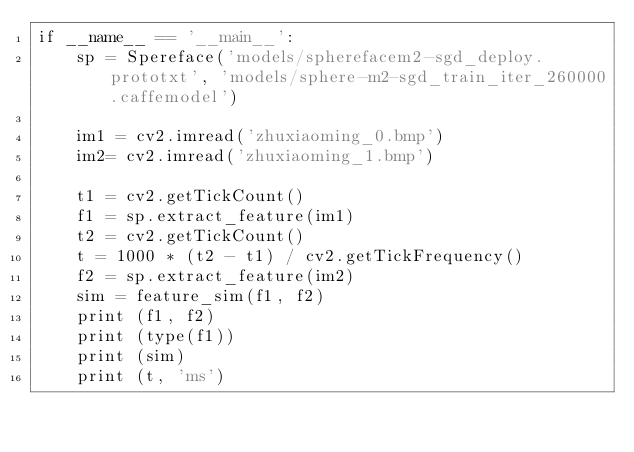Convert code to text. <code><loc_0><loc_0><loc_500><loc_500><_Python_>if __name__ == '__main__':
    sp = Spereface('models/spherefacem2-sgd_deploy.prototxt', 'models/sphere-m2-sgd_train_iter_260000.caffemodel')

    im1 = cv2.imread('zhuxiaoming_0.bmp')
    im2= cv2.imread('zhuxiaoming_1.bmp')

    t1 = cv2.getTickCount()
    f1 = sp.extract_feature(im1)
    t2 = cv2.getTickCount()
    t = 1000 * (t2 - t1) / cv2.getTickFrequency()
    f2 = sp.extract_feature(im2)
    sim = feature_sim(f1, f2)
    print (f1, f2)
    print (type(f1))
    print (sim)
    print (t, 'ms')</code> 